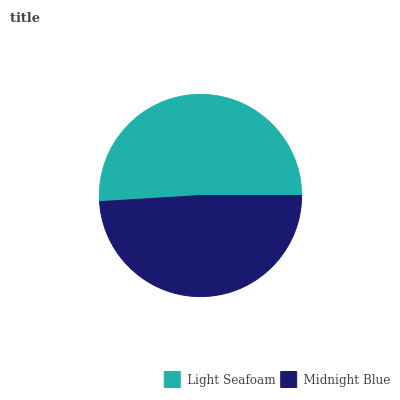Is Midnight Blue the minimum?
Answer yes or no. Yes. Is Light Seafoam the maximum?
Answer yes or no. Yes. Is Midnight Blue the maximum?
Answer yes or no. No. Is Light Seafoam greater than Midnight Blue?
Answer yes or no. Yes. Is Midnight Blue less than Light Seafoam?
Answer yes or no. Yes. Is Midnight Blue greater than Light Seafoam?
Answer yes or no. No. Is Light Seafoam less than Midnight Blue?
Answer yes or no. No. Is Light Seafoam the high median?
Answer yes or no. Yes. Is Midnight Blue the low median?
Answer yes or no. Yes. Is Midnight Blue the high median?
Answer yes or no. No. Is Light Seafoam the low median?
Answer yes or no. No. 